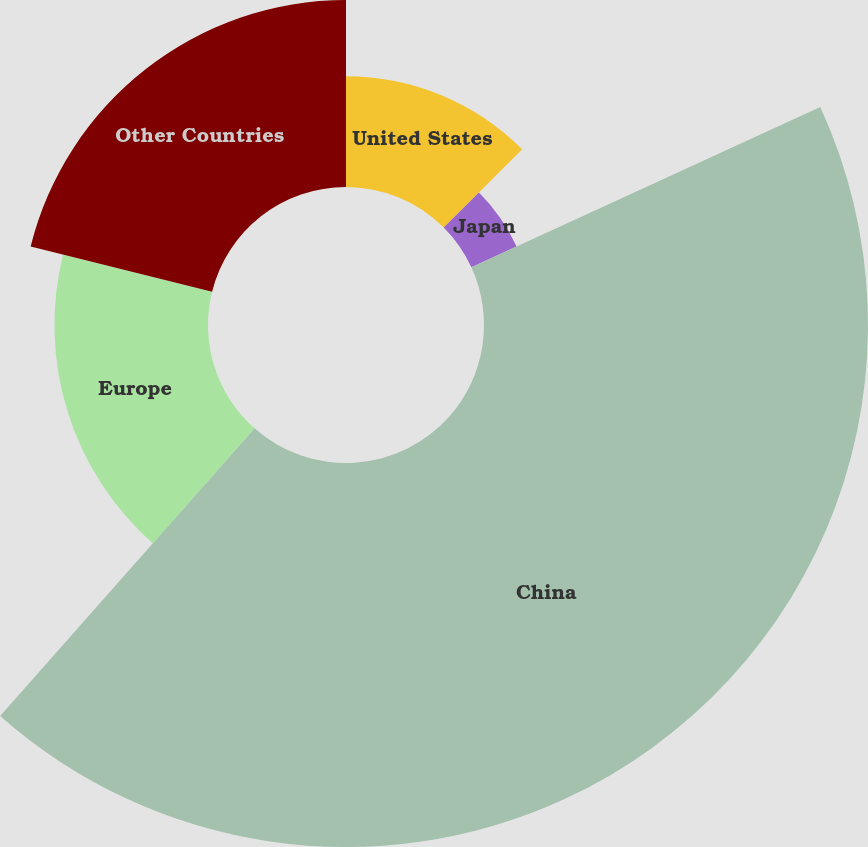<chart> <loc_0><loc_0><loc_500><loc_500><pie_chart><fcel>United States<fcel>Japan<fcel>China<fcel>Europe<fcel>Other Countries<nl><fcel>12.52%<fcel>5.62%<fcel>43.38%<fcel>17.35%<fcel>21.12%<nl></chart> 